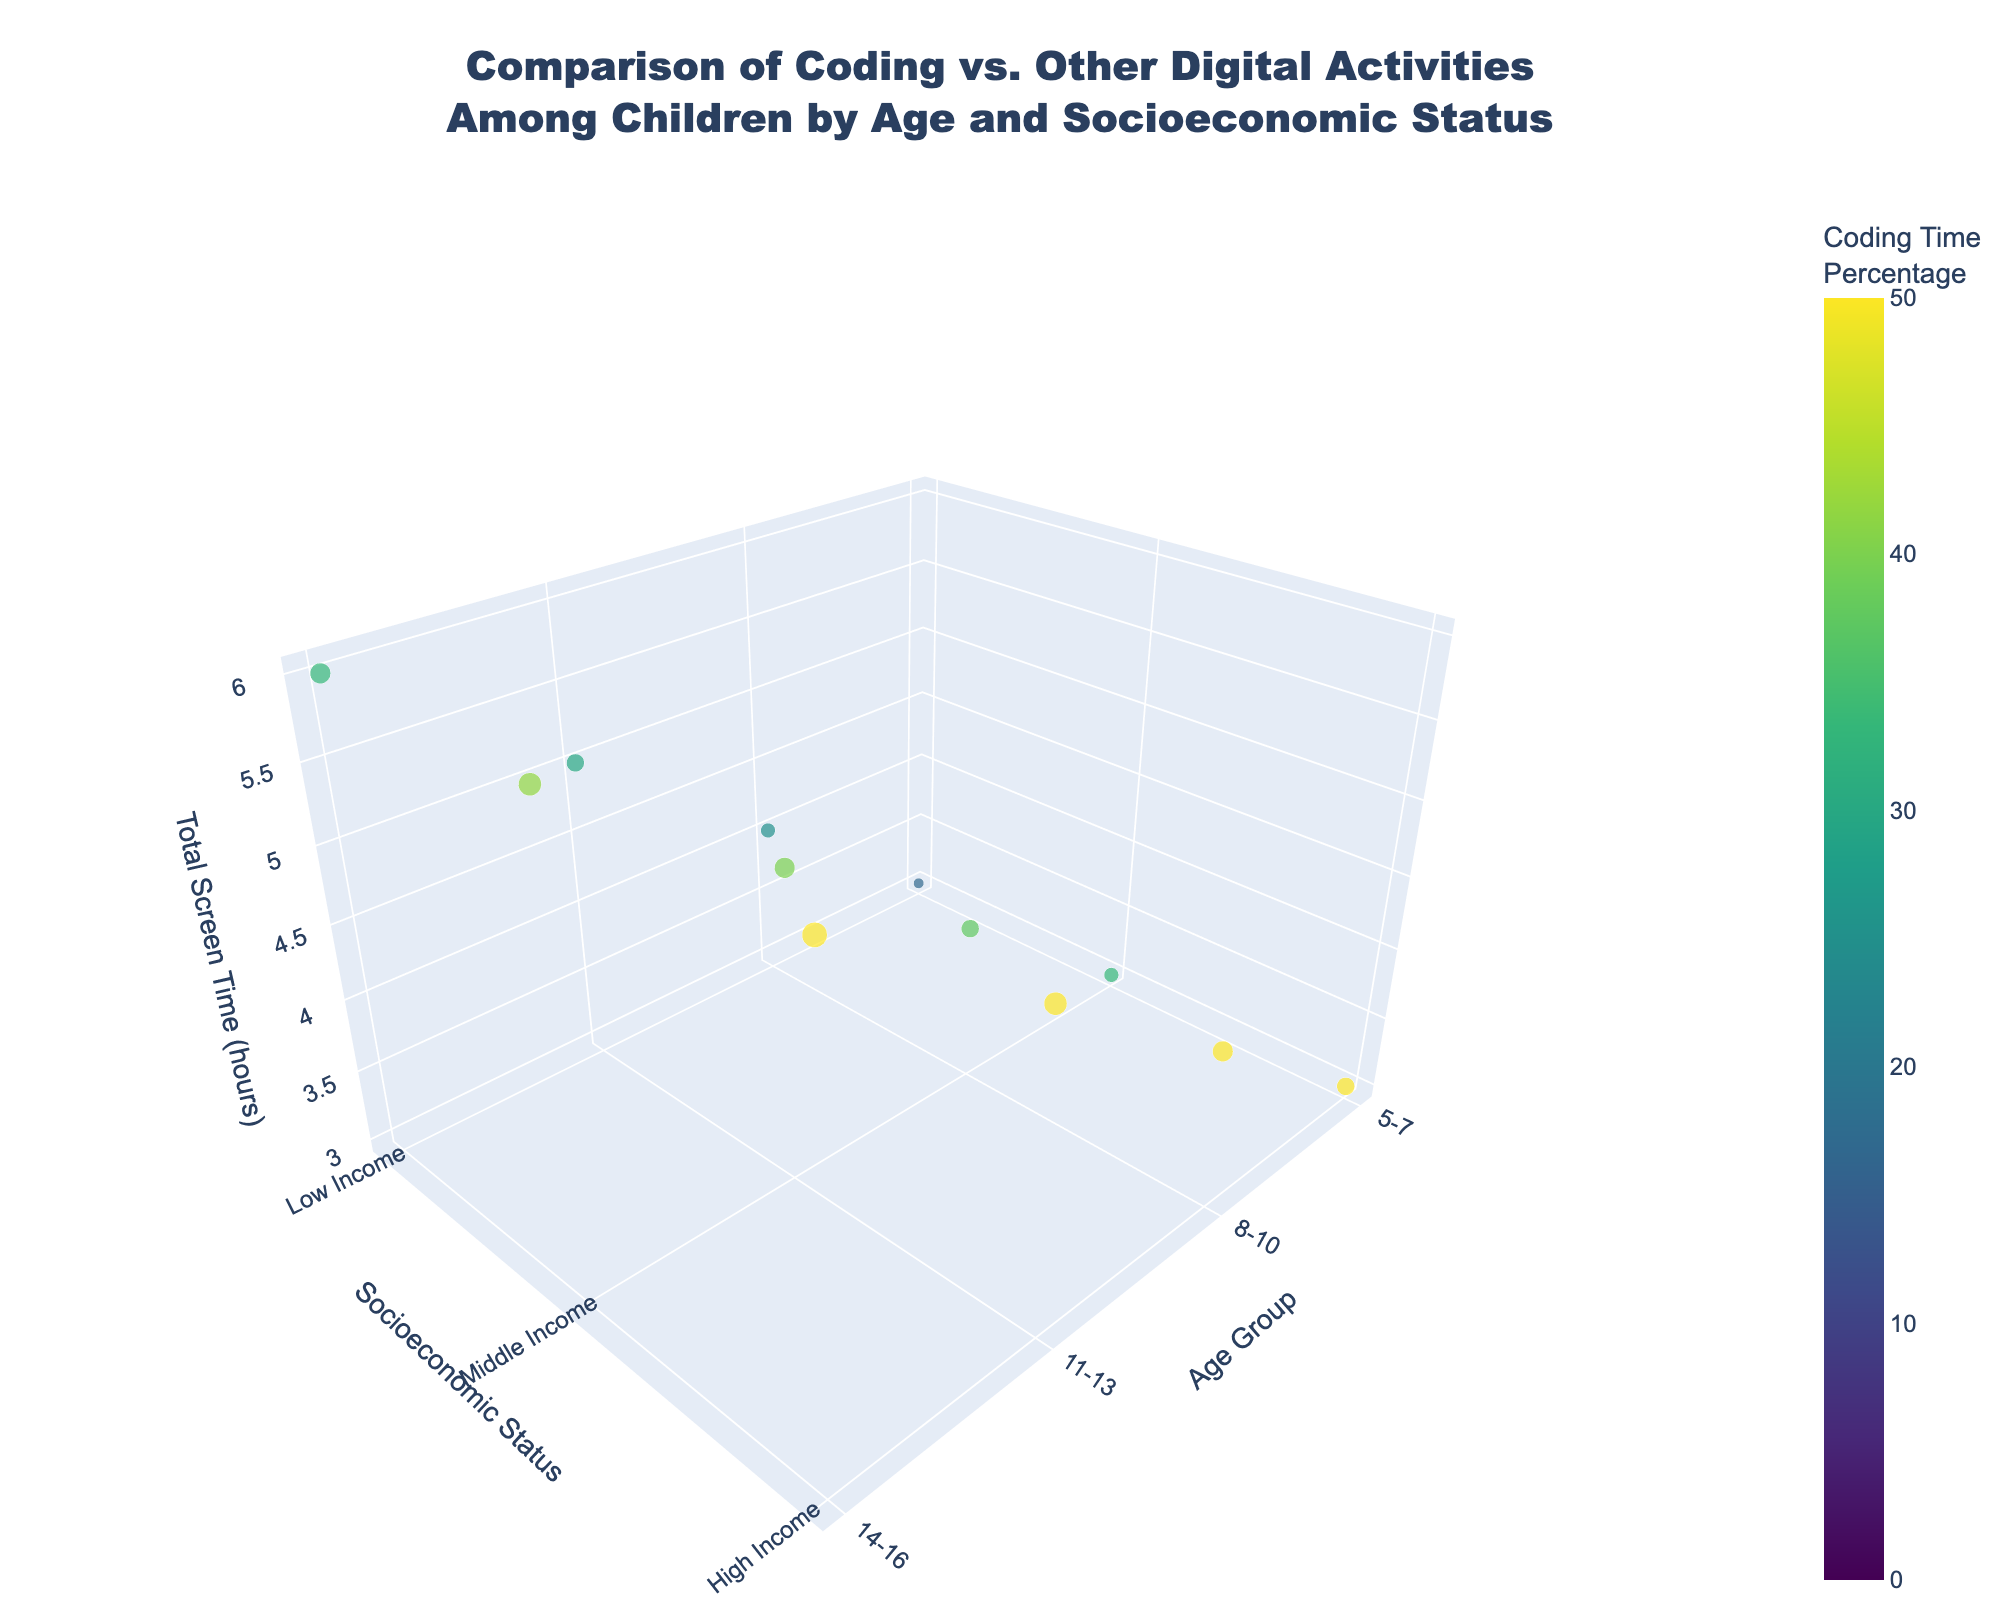What is the total screen time for children aged 5-7 from low-income families? According to the age group of 5-7 and low-income status, the total screen time is found by looking at the respective row, which is 3.0 hours.
Answer: 3.0 hours Which age group has the highest coding percentage for high-income families? For high-income families, we look at the coding percentage columns for each age group: 5-7 (50%), 8-10 (50%), 11-13 (50%), and 14-16 (50%). All groups have the same coding percentage, so they all equally have the highest percentage.
Answer: All age groups (50%) Compare the coding screen time between children aged 8-10 from low-income and high-income families. Which group has more coding screen time? By looking at the age group 8-10, we see that low-income families have a coding screen time of 1.0 hours, whereas high-income families have 2.0 hours.
Answer: High-income families What is the difference in total screen time between children aged 14-16 from low-income and high-income families? For the age group 14-16, the total screen time for low-income families is 6.0 hours and for high-income families, it's also 6.0 hours. The difference is 6.0 - 6.0.
Answer: 0 hours Which socioeconomic group has the highest total screen time in the 11-13 age group? In the 11-13 age group, low-income has 5.0 hours, middle-income has 5.0 hours, and high-income has 5.0 hours. All socioeconomic groups have the same total screen time.
Answer: All have the highest (5.0 hours) What is the average coding screen time for children aged 8-10 across all socioeconomic statuses? For the age group 8-10, coding screen times are: low-income (1.0), middle-income (1.5), and high-income (2.0). The average is calculated as (1.0 + 1.5 + 2.0) / 3.
Answer: 1.5 hours For children aged 14-16 from middle-income families, what proportion of their total screen time is dedicated to coding? In the 14-16 age group, middle-income families have 2.5 hours of coding out of 6.0 hours total screen time. The proportion is (2.5 / 6.0) * 100%.
Answer: 41.7% Which age group shows the greatest variation in total screen time across different socioeconomic statuses? The age groups have the following variations (max - min total screen time):
- 5-7: 3.0 - 3.0 = 0
- 8-10: 4.0 - 4.0 = 0
- 11-13: 5.0 - 5.0 = 0
- 14-16: 6.0 - 6.0 = 0
All variations are 0, indicating no variation.
Answer: No variation 